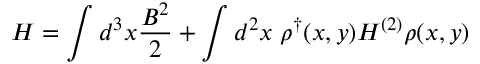<formula> <loc_0><loc_0><loc_500><loc_500>H = \int d ^ { 3 } x \frac { B ^ { 2 } } { 2 } + \int d ^ { 2 } x \, \rho ^ { \dag } ( x , y ) H ^ { ( 2 ) } \rho ( x , y )</formula> 